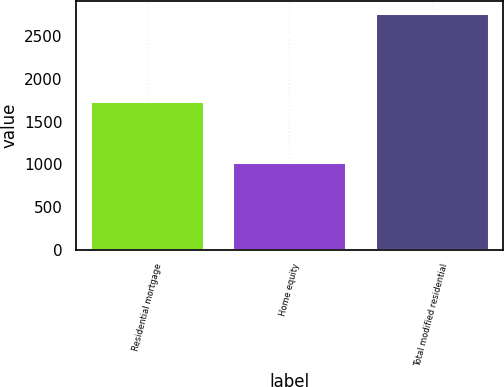Convert chart to OTSL. <chart><loc_0><loc_0><loc_500><loc_500><bar_chart><fcel>Residential mortgage<fcel>Home equity<fcel>Total modified residential<nl><fcel>1743<fcel>1032<fcel>2775<nl></chart> 